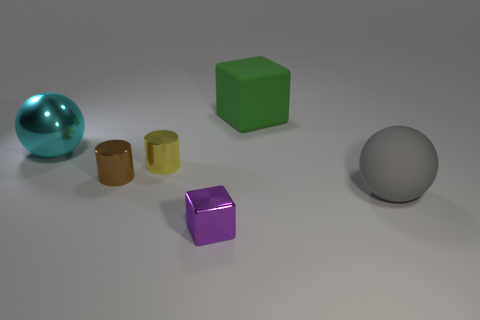Add 2 tiny yellow metallic cubes. How many objects exist? 8 Subtract all blocks. How many objects are left? 4 Add 2 large shiny spheres. How many large shiny spheres exist? 3 Subtract 0 brown blocks. How many objects are left? 6 Subtract all brown metallic cylinders. Subtract all purple cubes. How many objects are left? 4 Add 1 big things. How many big things are left? 4 